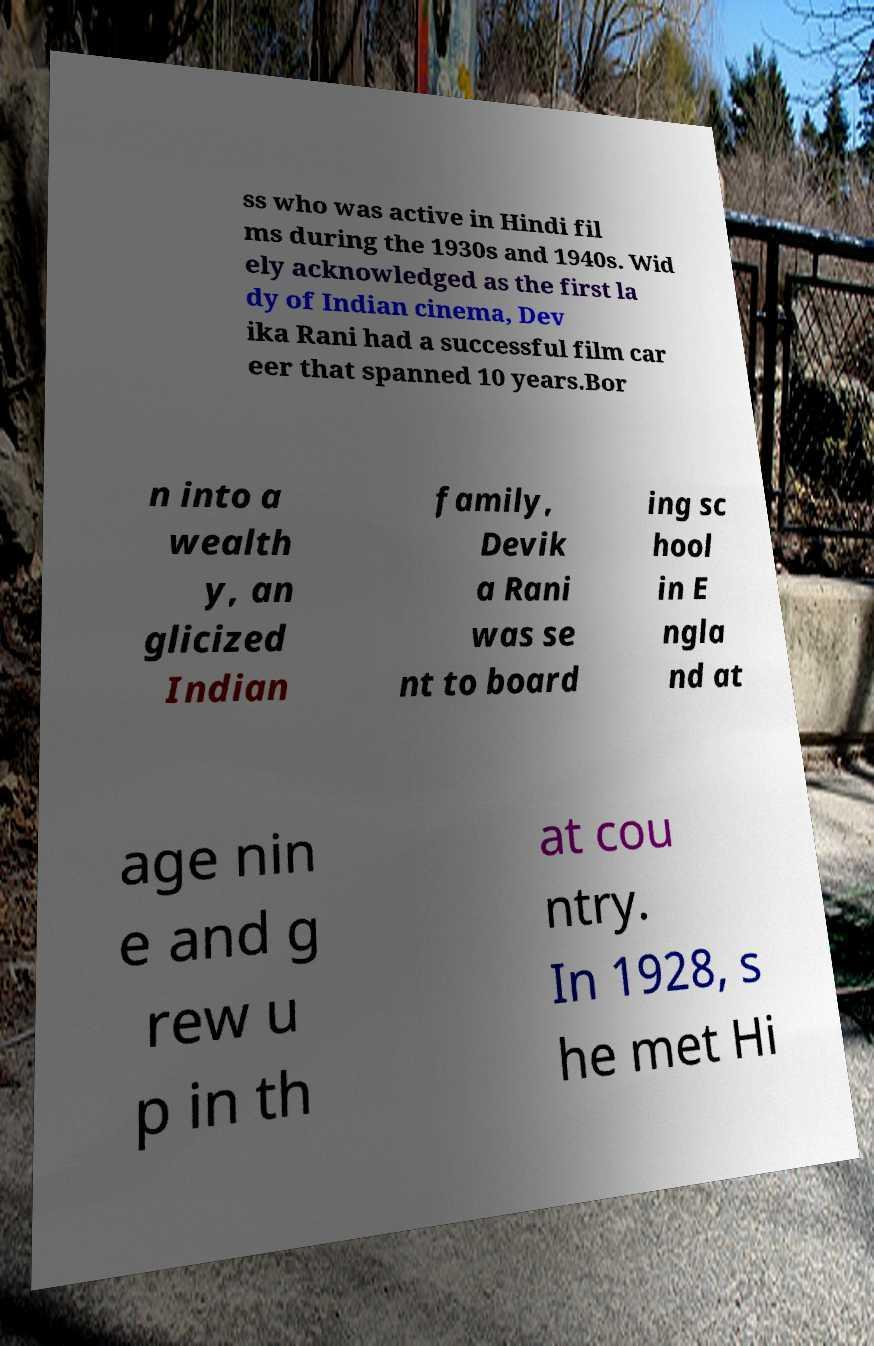Could you extract and type out the text from this image? ss who was active in Hindi fil ms during the 1930s and 1940s. Wid ely acknowledged as the first la dy of Indian cinema, Dev ika Rani had a successful film car eer that spanned 10 years.Bor n into a wealth y, an glicized Indian family, Devik a Rani was se nt to board ing sc hool in E ngla nd at age nin e and g rew u p in th at cou ntry. In 1928, s he met Hi 